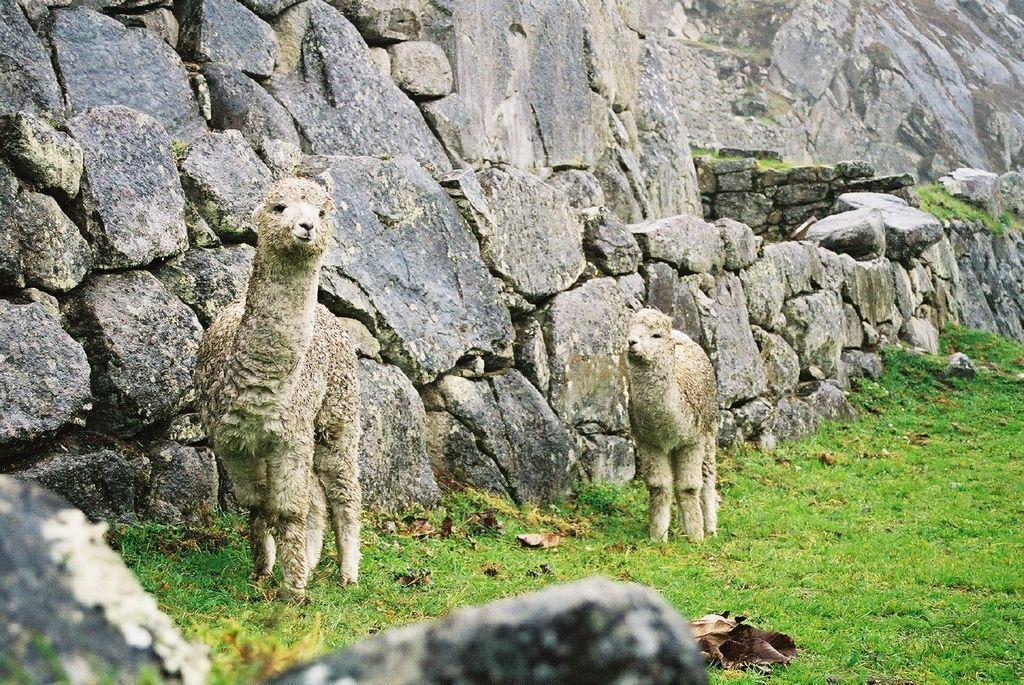How would you summarize this image in a sentence or two? In the picture I can see animals standing on the ground. In the background I can see the grass and wall. 